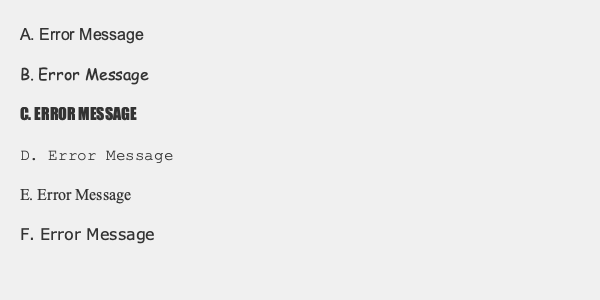Which typography option would be most effective for error message headers in software applications, considering both readability and user experience? To determine the most effective typography for error message headers, we need to consider several factors:

1. Readability: The font should be clear and easy to read at a glance.
2. Professionalism: The typography should convey a sense of reliability and trust.
3. Emotion: The font should not evoke unnecessary anxiety or humor.
4. Consistency: The typography should align with common design practices for error messages.

Let's analyze each option:

A. Arial: A sans-serif font that is clean, professional, and highly readable.
B. Comic Sans MS: Informal and playful, not suitable for error messages.
C. Impact: All caps and bold, may appear too aggressive or alarming.
D. Courier New: A monospace font, associated with coding but less readable for general users.
E. Times New Roman: A serif font, less commonly used in digital interfaces.
F. Verdana: A sans-serif font designed for screen readability, similar to Arial but with slight advantages.

Considering these factors, the most effective options are A (Arial) and F (Verdana). Both are sans-serif fonts that offer excellent readability on screens. However, Verdana has a slight edge as it was specifically designed for on-screen legibility, with wider characters and more open spacing.
Answer: Verdana 